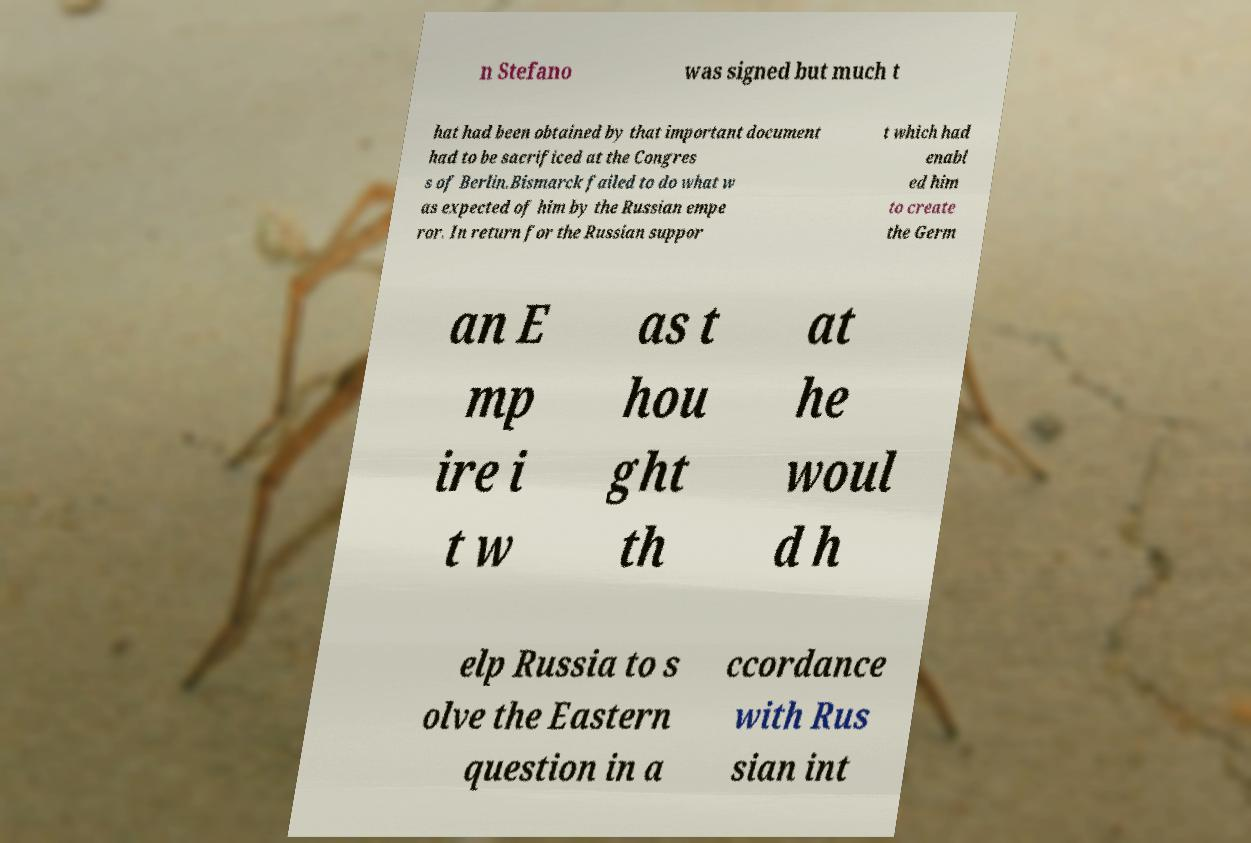Can you accurately transcribe the text from the provided image for me? n Stefano was signed but much t hat had been obtained by that important document had to be sacrificed at the Congres s of Berlin.Bismarck failed to do what w as expected of him by the Russian empe ror. In return for the Russian suppor t which had enabl ed him to create the Germ an E mp ire i t w as t hou ght th at he woul d h elp Russia to s olve the Eastern question in a ccordance with Rus sian int 